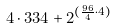<formula> <loc_0><loc_0><loc_500><loc_500>4 \cdot 3 3 4 + 2 ^ { ( \frac { 9 6 } { 4 } \cdot 4 ) }</formula> 